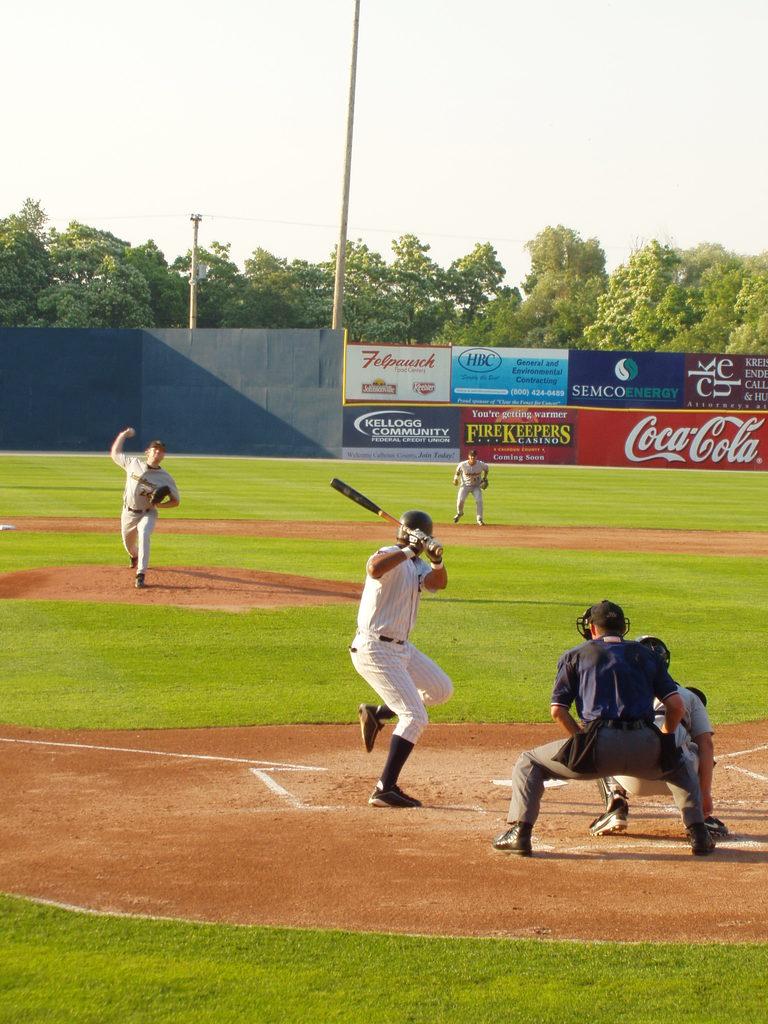What major soda brand sponsors this field?
Keep it short and to the point. Coca cola. What does the ad on the left of the coca cola say?
Offer a very short reply. Firekeepers. 